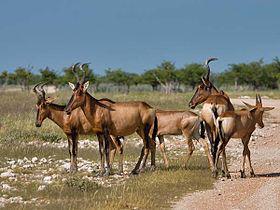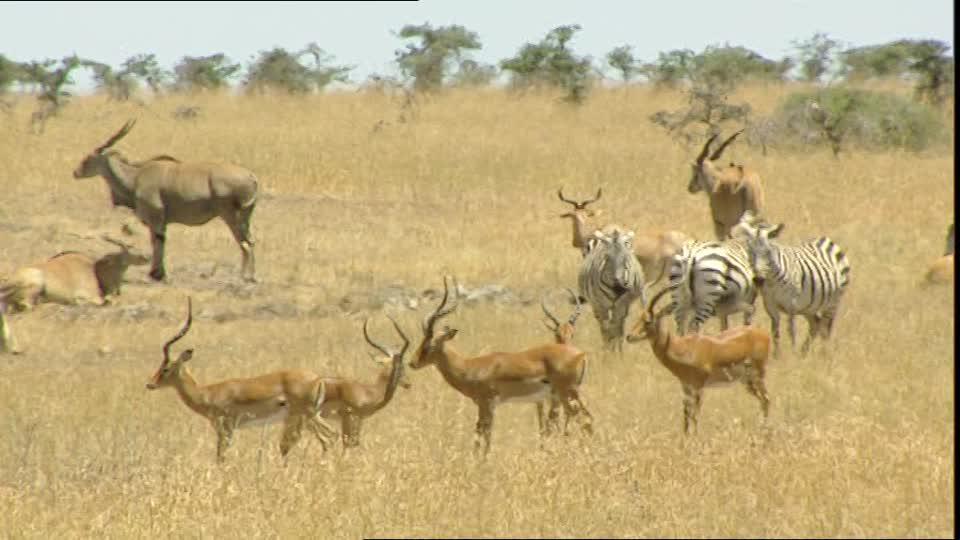The first image is the image on the left, the second image is the image on the right. For the images displayed, is the sentence "The right photo contains two kinds of animals." factually correct? Answer yes or no. Yes. The first image is the image on the left, the second image is the image on the right. Given the left and right images, does the statement "Zebra are present in a field with horned animals in one image." hold true? Answer yes or no. Yes. 